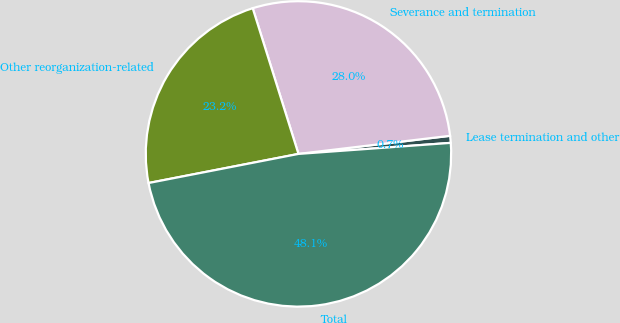Convert chart to OTSL. <chart><loc_0><loc_0><loc_500><loc_500><pie_chart><fcel>Lease termination and other<fcel>Severance and termination<fcel>Other reorganization-related<fcel>Total<nl><fcel>0.74%<fcel>27.95%<fcel>23.21%<fcel>48.1%<nl></chart> 